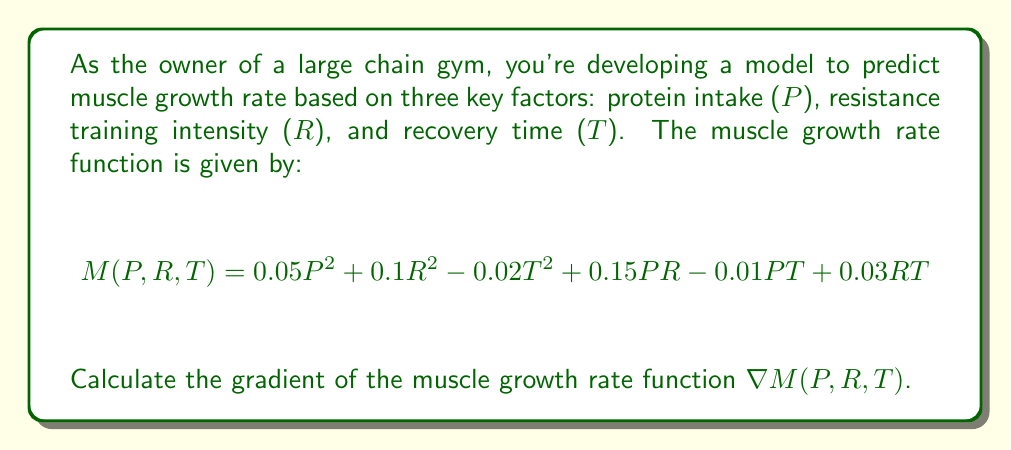Could you help me with this problem? To calculate the gradient of the muscle growth rate function $M(P, R, T)$, we need to find the partial derivatives with respect to each variable: P, R, and T.

Step 1: Calculate $\frac{\partial M}{\partial P}$
$$\frac{\partial M}{\partial P} = 0.1P + 0.15R - 0.01T$$

Step 2: Calculate $\frac{\partial M}{\partial R}$
$$\frac{\partial M}{\partial R} = 0.2R + 0.15P + 0.03T$$

Step 3: Calculate $\frac{\partial M}{\partial T}$
$$\frac{\partial M}{\partial T} = -0.04T - 0.01P + 0.03R$$

Step 4: Combine the partial derivatives to form the gradient
The gradient is a vector of these partial derivatives:

$$\nabla M(P, R, T) = \left(\frac{\partial M}{\partial P}, \frac{\partial M}{\partial R}, \frac{\partial M}{\partial T}\right)$$

Substituting the calculated partial derivatives:

$$\nabla M(P, R, T) = (0.1P + 0.15R - 0.01T, 0.2R + 0.15P + 0.03T, -0.04T - 0.01P + 0.03R)$$
Answer: $$\nabla M(P, R, T) = (0.1P + 0.15R - 0.01T, 0.2R + 0.15P + 0.03T, -0.04T - 0.01P + 0.03R)$$ 